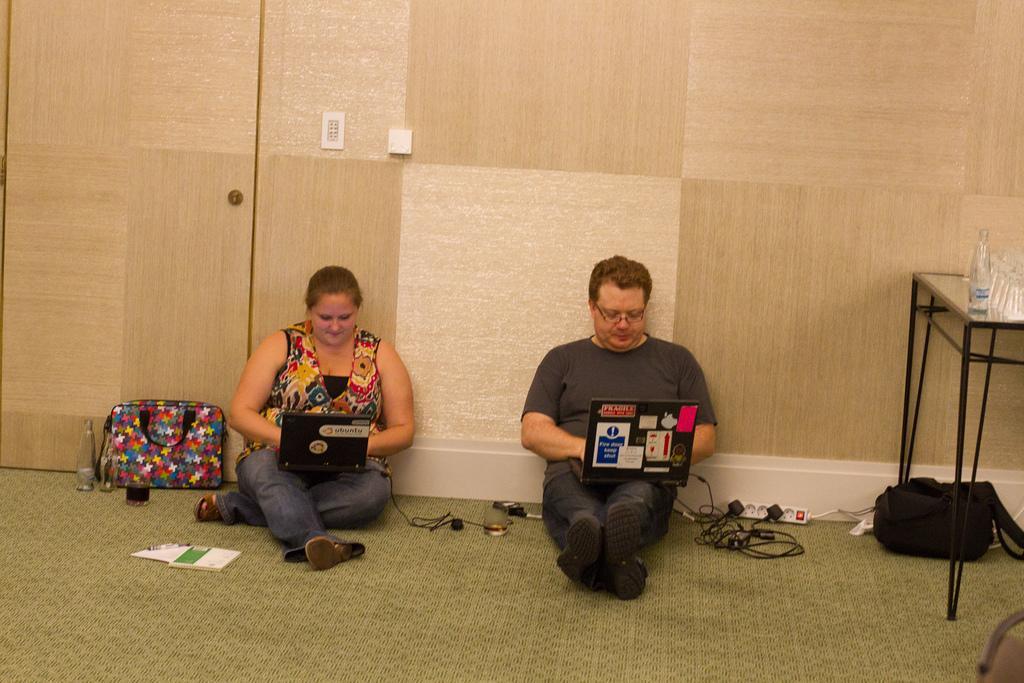Please provide a concise description of this image. In this image we can see a man and woman are sitting on the floor, they are holding laptop in their hands. Right side of the image one table is there, on the table bottles are present. Under the table one black color bag is there. Behind it switch board is there and wires are attached to the switch board. to the left side of the image one colorful bag, glass and bottle is present. In front of the lady papers are present. Background of the image brown color wall is there. 